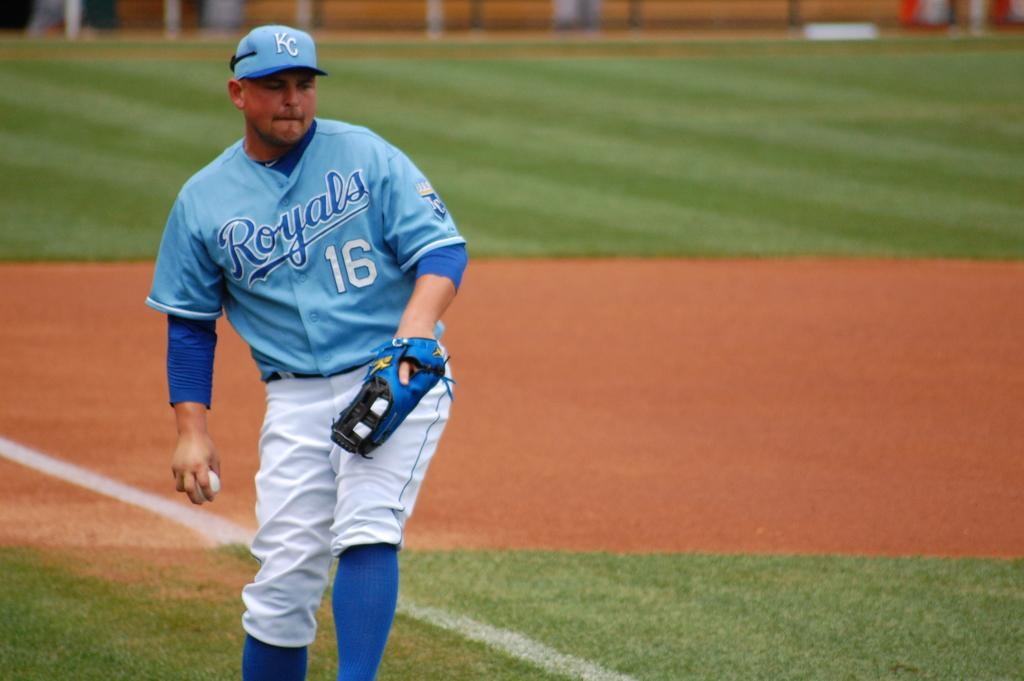<image>
Describe the image concisely. A royals player wearing number 16 prepares to throw the ball. 